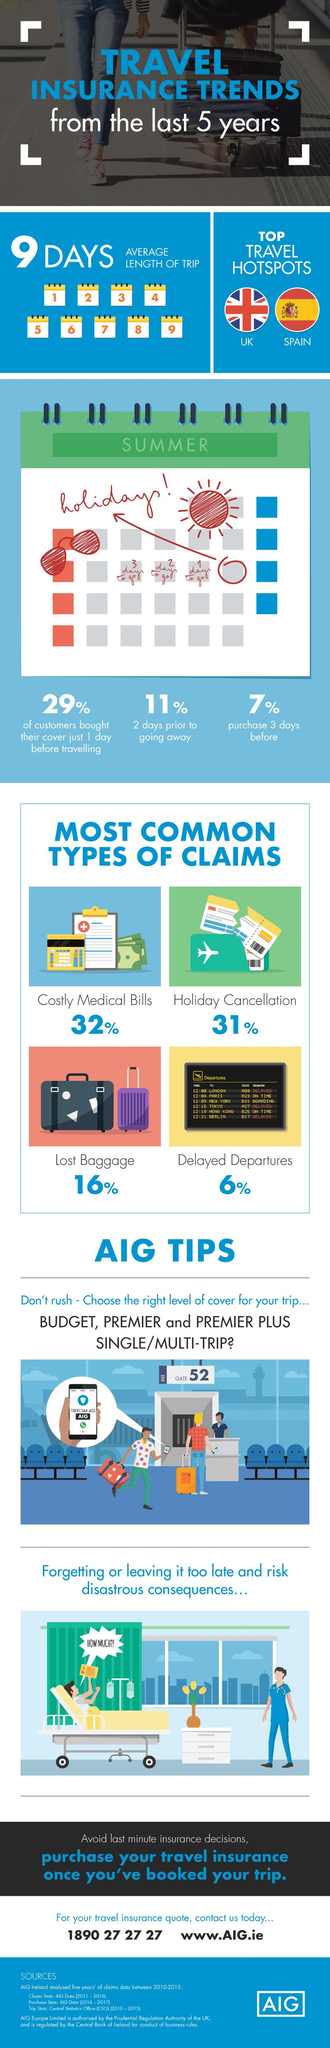List a handful of essential elements in this visual. The travel insurance company written on the smart phone is AIG. The green portion of the calendar bears the inscription SUMMER, indicating the current season. According to data, approximately 16% of insurance claims are due to delayed departures. Conversely, 6% of insurance claims and 31% of insurance claims are not attributed to delayed departures. The customer care number for AIG, as displayed on the mobile screen, is 1800 344 455. There are two countries that are sought after as popular destinations for travel. 